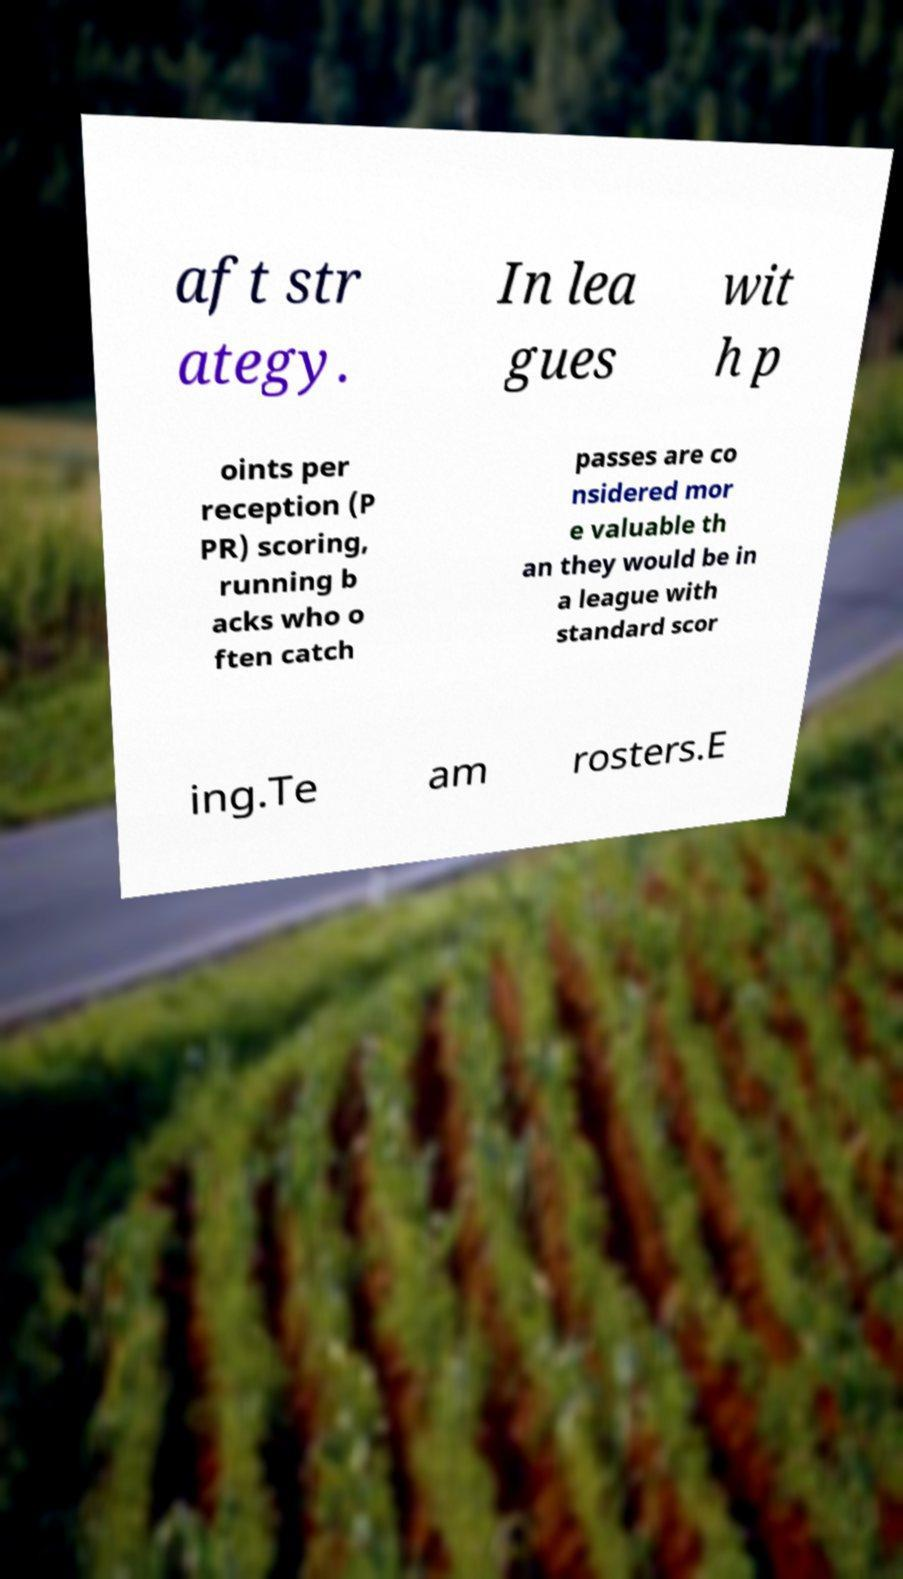I need the written content from this picture converted into text. Can you do that? aft str ategy. In lea gues wit h p oints per reception (P PR) scoring, running b acks who o ften catch passes are co nsidered mor e valuable th an they would be in a league with standard scor ing.Te am rosters.E 